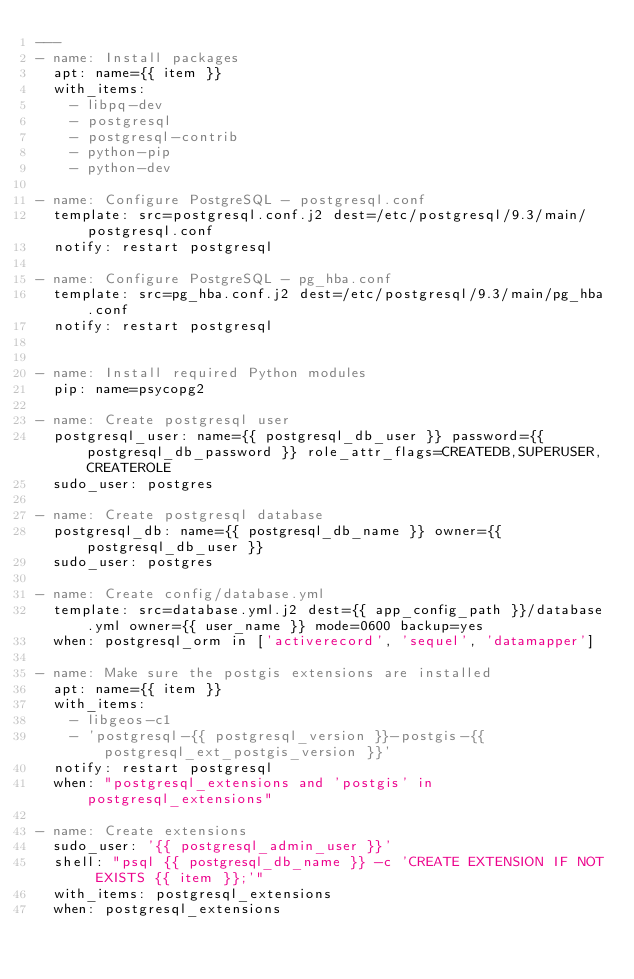Convert code to text. <code><loc_0><loc_0><loc_500><loc_500><_YAML_>---
- name: Install packages
  apt: name={{ item }}
  with_items:
    - libpq-dev
    - postgresql
    - postgresql-contrib
    - python-pip
    - python-dev

- name: Configure PostgreSQL - postgresql.conf
  template: src=postgresql.conf.j2 dest=/etc/postgresql/9.3/main/postgresql.conf
  notify: restart postgresql

- name: Configure PostgreSQL - pg_hba.conf
  template: src=pg_hba.conf.j2 dest=/etc/postgresql/9.3/main/pg_hba.conf
  notify: restart postgresql


- name: Install required Python modules
  pip: name=psycopg2

- name: Create postgresql user
  postgresql_user: name={{ postgresql_db_user }} password={{ postgresql_db_password }} role_attr_flags=CREATEDB,SUPERUSER,CREATEROLE
  sudo_user: postgres

- name: Create postgresql database
  postgresql_db: name={{ postgresql_db_name }} owner={{ postgresql_db_user }}
  sudo_user: postgres

- name: Create config/database.yml
  template: src=database.yml.j2 dest={{ app_config_path }}/database.yml owner={{ user_name }} mode=0600 backup=yes
  when: postgresql_orm in ['activerecord', 'sequel', 'datamapper']

- name: Make sure the postgis extensions are installed
  apt: name={{ item }}
  with_items:
    - libgeos-c1
    - 'postgresql-{{ postgresql_version }}-postgis-{{ postgresql_ext_postgis_version }}'
  notify: restart postgresql
  when: "postgresql_extensions and 'postgis' in postgresql_extensions"

- name: Create extensions
  sudo_user: '{{ postgresql_admin_user }}'
  shell: "psql {{ postgresql_db_name }} -c 'CREATE EXTENSION IF NOT EXISTS {{ item }};'"
  with_items: postgresql_extensions
  when: postgresql_extensions
</code> 